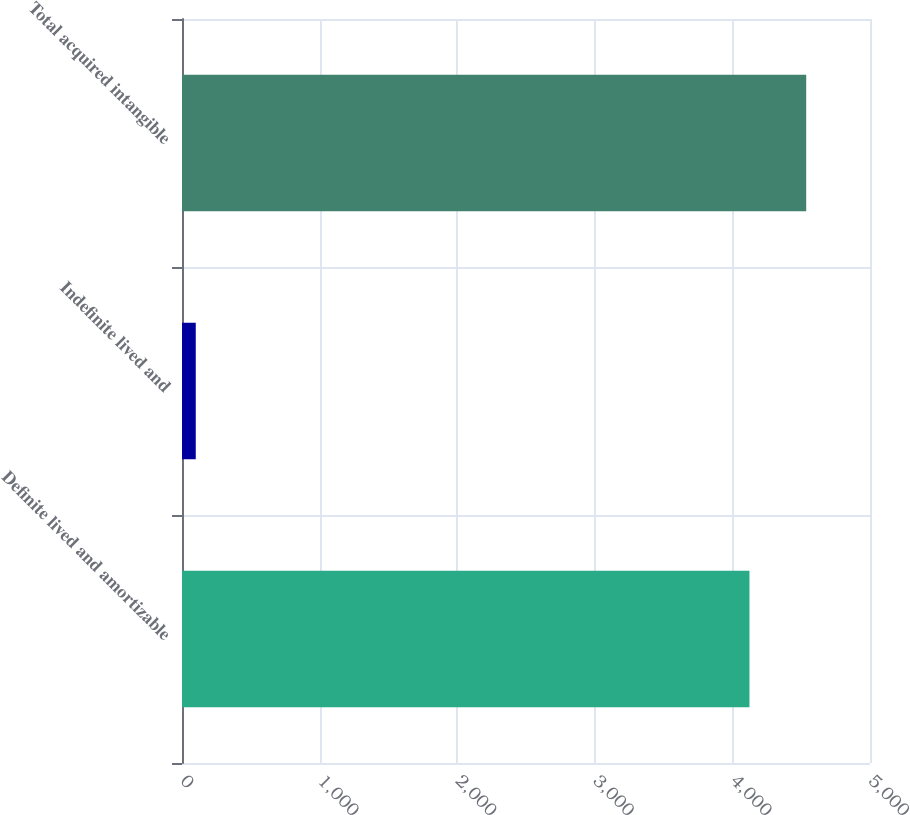<chart> <loc_0><loc_0><loc_500><loc_500><bar_chart><fcel>Definite lived and amortizable<fcel>Indefinite lived and<fcel>Total acquired intangible<nl><fcel>4124<fcel>100<fcel>4536.4<nl></chart> 